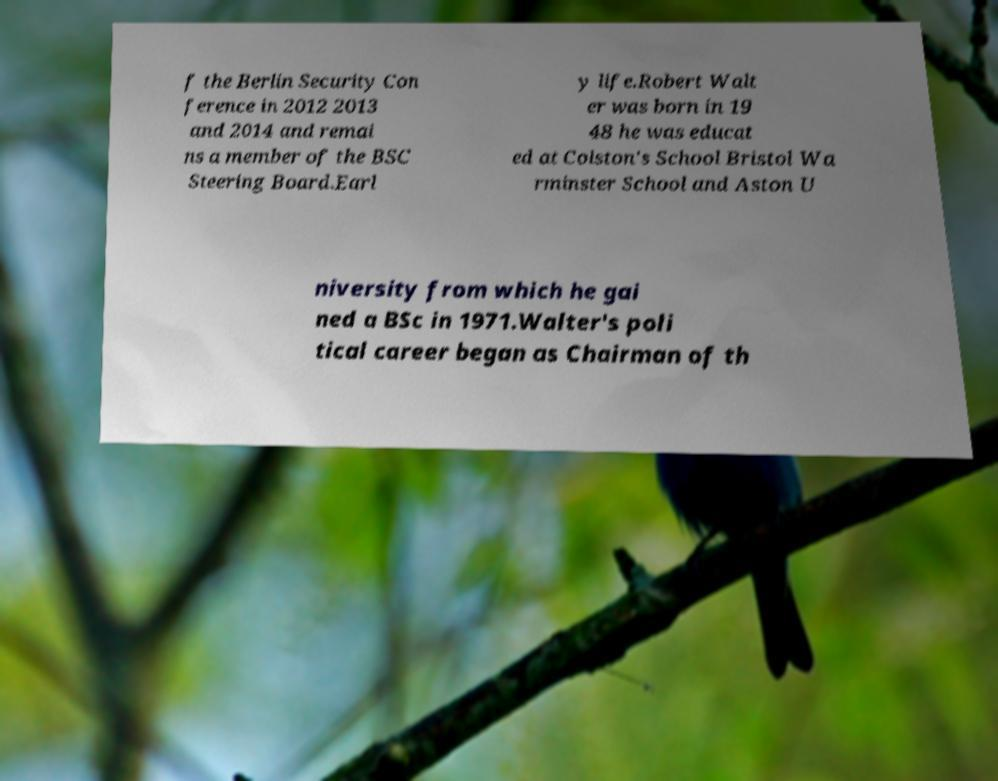Can you read and provide the text displayed in the image?This photo seems to have some interesting text. Can you extract and type it out for me? f the Berlin Security Con ference in 2012 2013 and 2014 and remai ns a member of the BSC Steering Board.Earl y life.Robert Walt er was born in 19 48 he was educat ed at Colston's School Bristol Wa rminster School and Aston U niversity from which he gai ned a BSc in 1971.Walter's poli tical career began as Chairman of th 